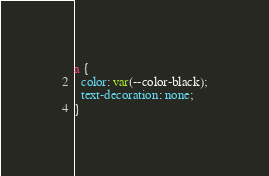Convert code to text. <code><loc_0><loc_0><loc_500><loc_500><_CSS_>
a {
  color: var(--color-black);
  text-decoration: none;
}
</code> 